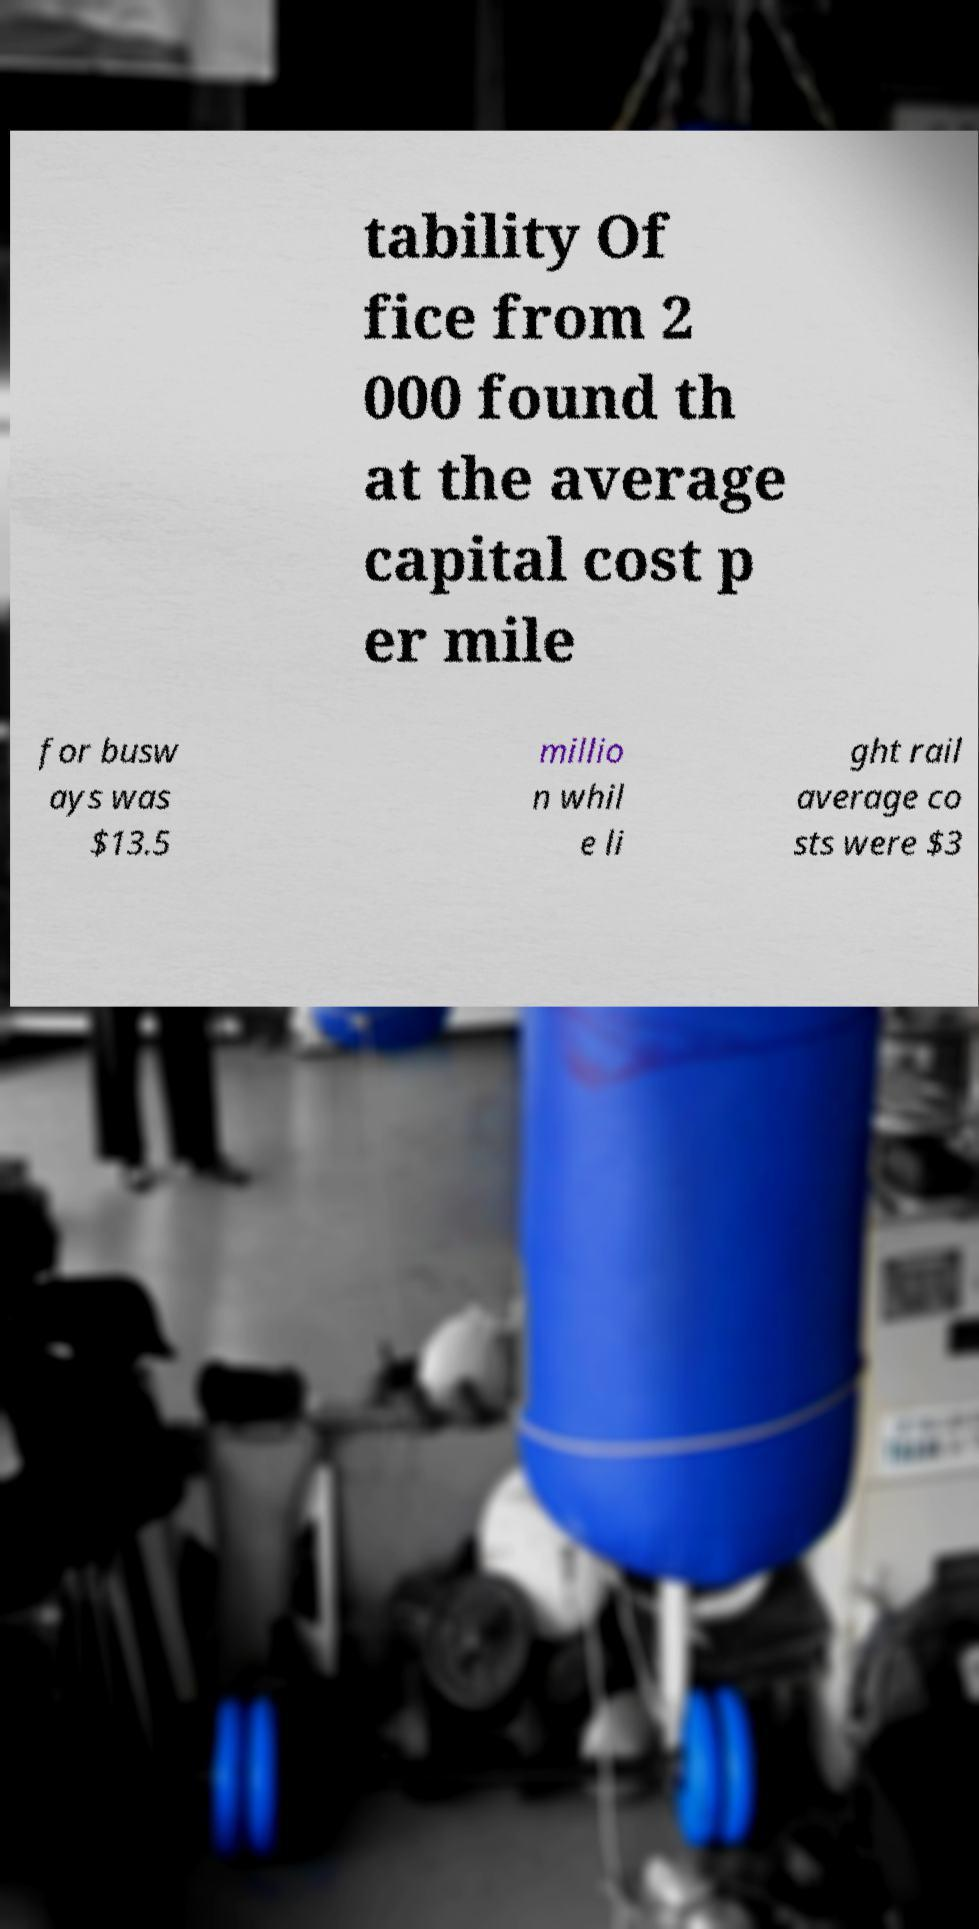What messages or text are displayed in this image? I need them in a readable, typed format. tability Of fice from 2 000 found th at the average capital cost p er mile for busw ays was $13.5 millio n whil e li ght rail average co sts were $3 